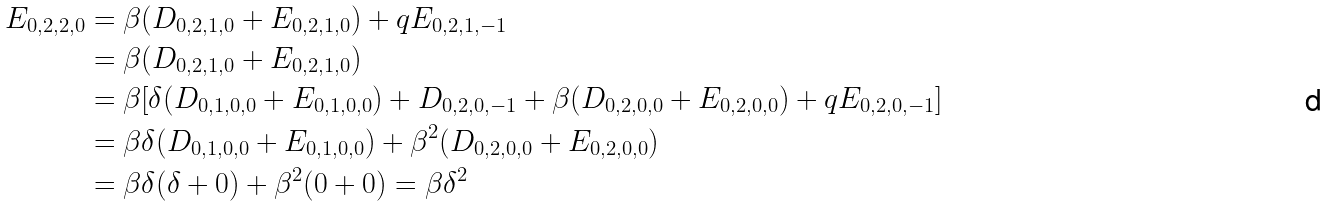Convert formula to latex. <formula><loc_0><loc_0><loc_500><loc_500>E _ { 0 , 2 , 2 , 0 } & = \beta ( D _ { 0 , 2 , 1 , 0 } + E _ { 0 , 2 , 1 , 0 } ) + q E _ { 0 , 2 , 1 , - 1 } \\ & = \beta ( D _ { 0 , 2 , 1 , 0 } + E _ { 0 , 2 , 1 , 0 } ) \\ & = \beta [ \delta ( D _ { 0 , 1 , 0 , 0 } + E _ { 0 , 1 , 0 , 0 } ) + D _ { 0 , 2 , 0 , - 1 } + \beta ( D _ { 0 , 2 , 0 , 0 } + E _ { 0 , 2 , 0 , 0 } ) + q E _ { 0 , 2 , 0 , - 1 } ] \\ & = \beta \delta ( D _ { 0 , 1 , 0 , 0 } + E _ { 0 , 1 , 0 , 0 } ) + \beta ^ { 2 } ( D _ { 0 , 2 , 0 , 0 } + E _ { 0 , 2 , 0 , 0 } ) \\ & = \beta \delta ( \delta + 0 ) + \beta ^ { 2 } ( 0 + 0 ) = \beta \delta ^ { 2 }</formula> 